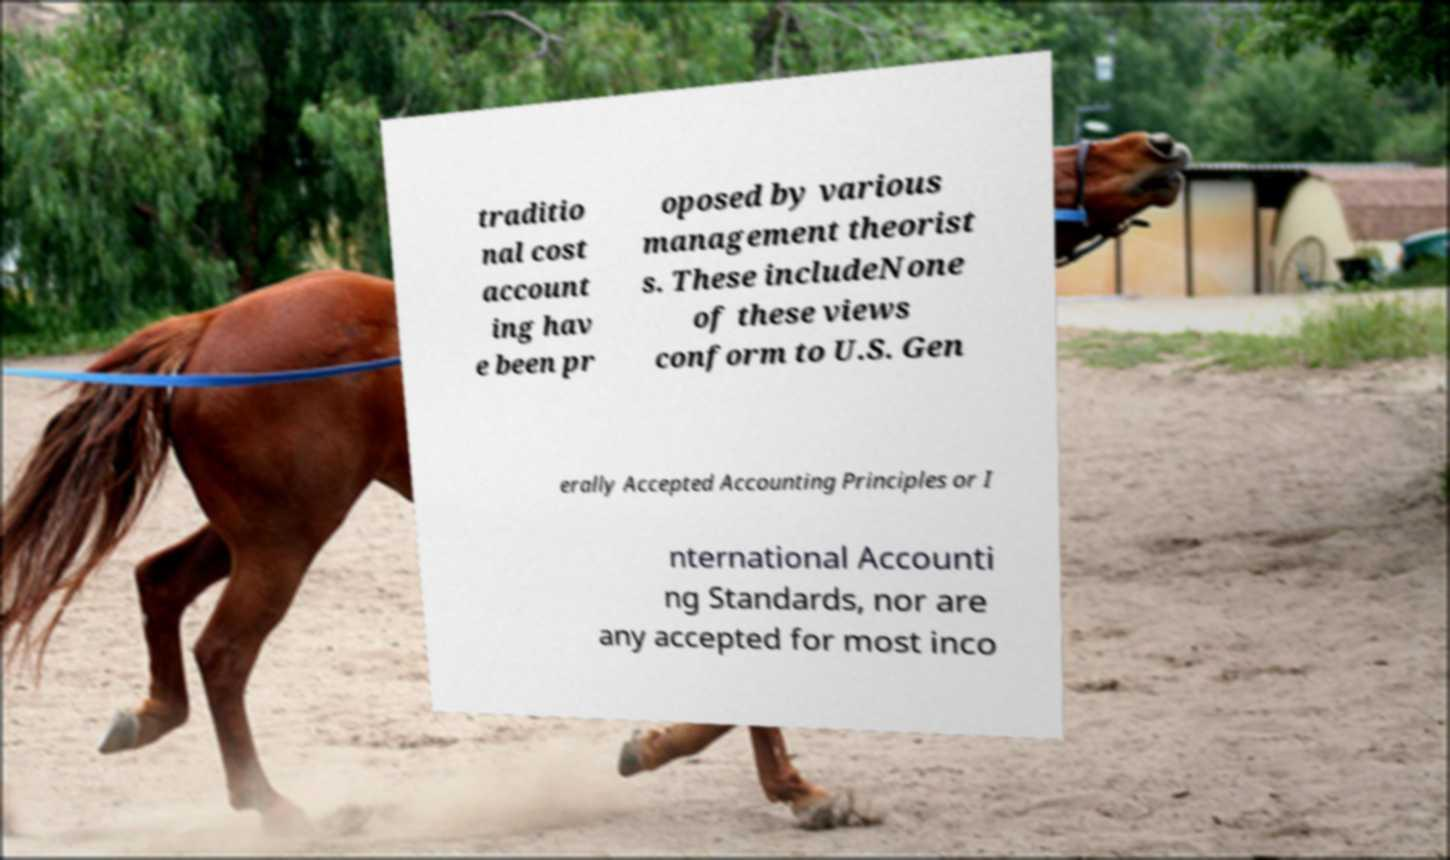Could you extract and type out the text from this image? traditio nal cost account ing hav e been pr oposed by various management theorist s. These includeNone of these views conform to U.S. Gen erally Accepted Accounting Principles or I nternational Accounti ng Standards, nor are any accepted for most inco 